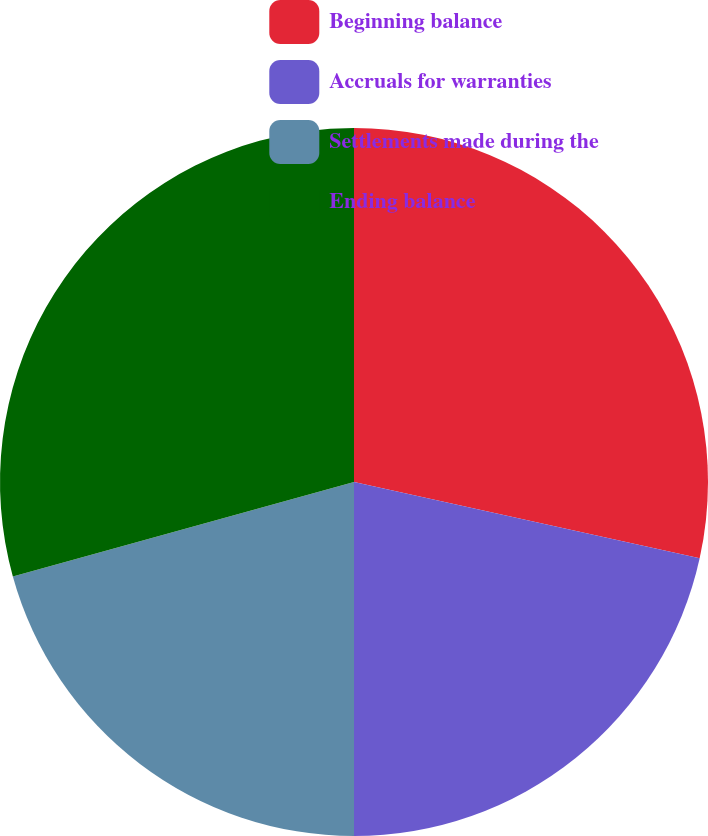Convert chart. <chart><loc_0><loc_0><loc_500><loc_500><pie_chart><fcel>Beginning balance<fcel>Accruals for warranties<fcel>Settlements made during the<fcel>Ending balance<nl><fcel>28.46%<fcel>21.54%<fcel>20.7%<fcel>29.3%<nl></chart> 